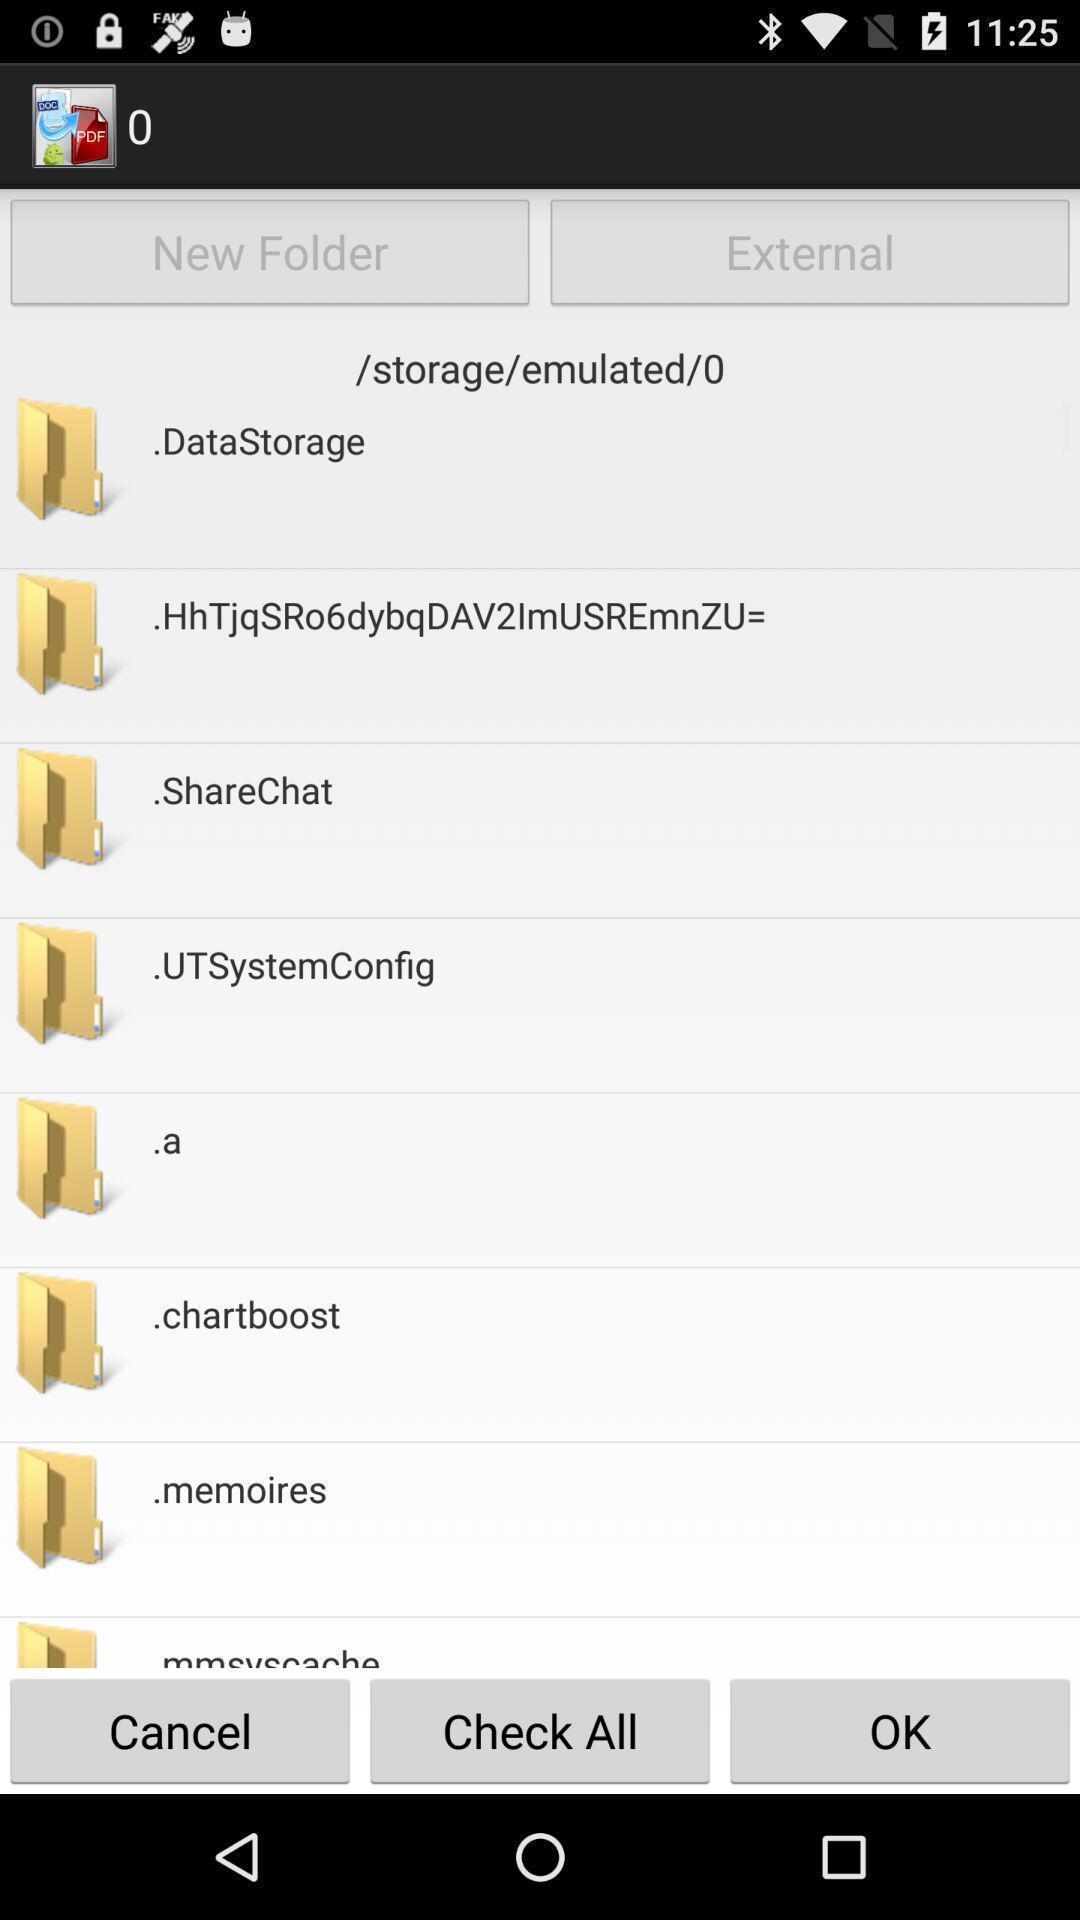What details can you identify in this image? Page showing files with cancel check all and ok options. 